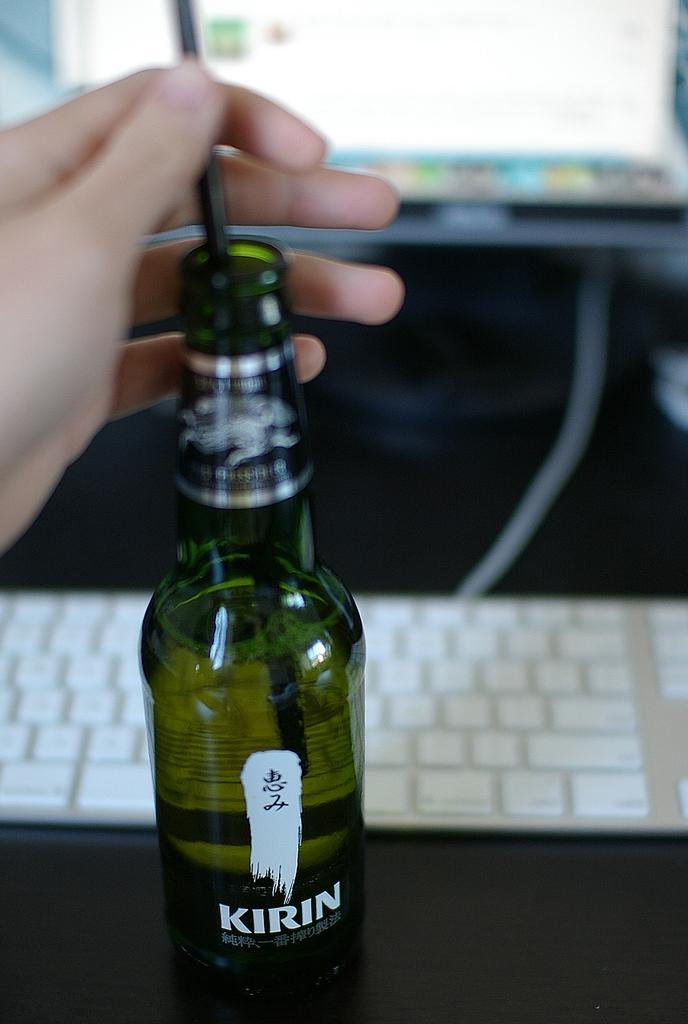<image>
Give a short and clear explanation of the subsequent image. A bottle of a drink called kirin next to a keyboard 